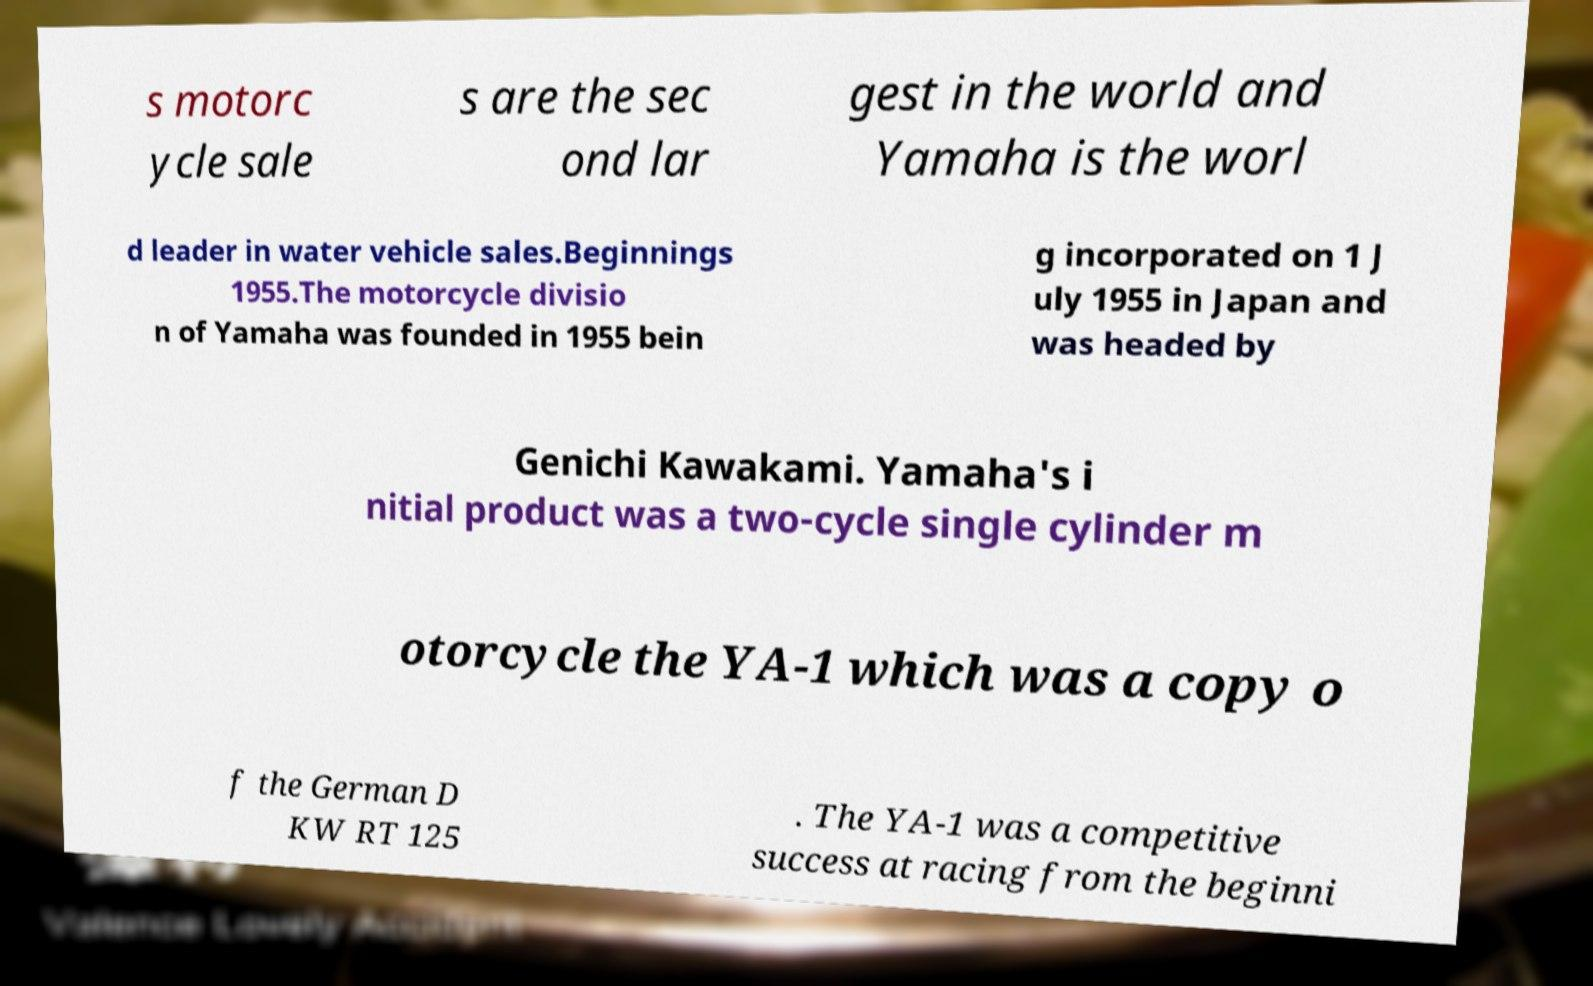Please read and relay the text visible in this image. What does it say? s motorc ycle sale s are the sec ond lar gest in the world and Yamaha is the worl d leader in water vehicle sales.Beginnings 1955.The motorcycle divisio n of Yamaha was founded in 1955 bein g incorporated on 1 J uly 1955 in Japan and was headed by Genichi Kawakami. Yamaha's i nitial product was a two-cycle single cylinder m otorcycle the YA-1 which was a copy o f the German D KW RT 125 . The YA-1 was a competitive success at racing from the beginni 